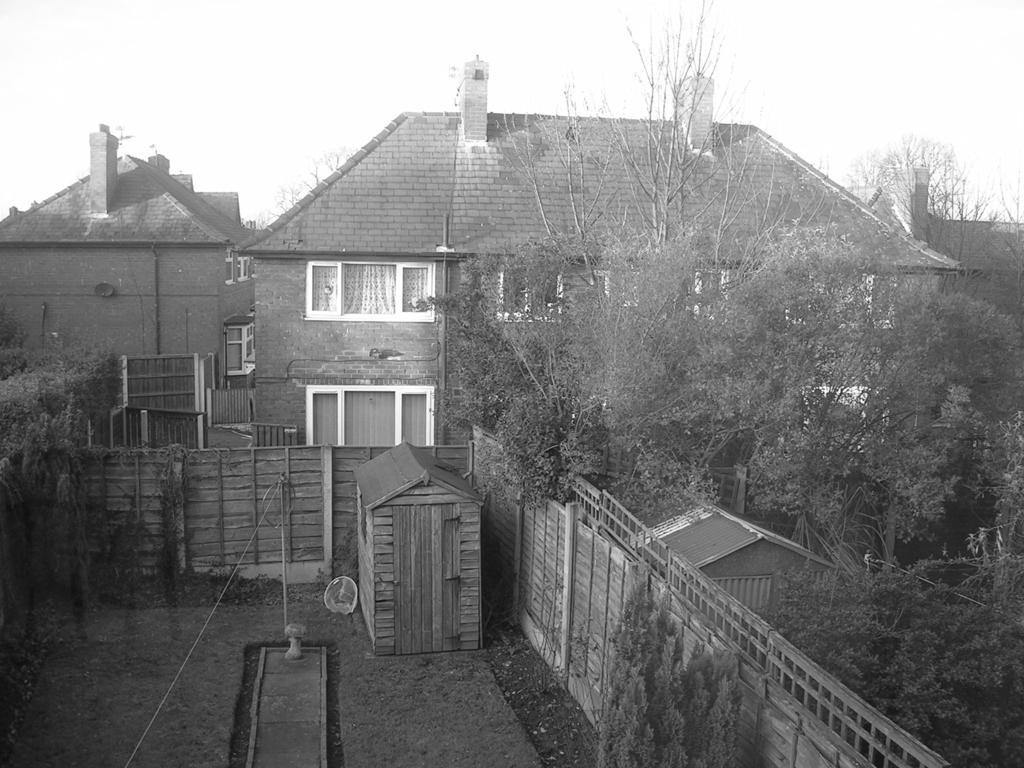What is one of the main objects in the image? There is a pole in the image. What is attached to the pole? There is a rope attached to the pole. What animals are present in the image? There are horses in the image. What type of vegetation can be seen in the image? There are plants and trees in the image. What type of structure is visible in the image? There is a wall and buildings in the image. What architectural feature can be seen in the image? There are windows in the image. What part of the natural environment is visible in the background of the image? The sky is visible in the background of the image. What type of mine can be seen in the image? There is no mine present in the image. How does the wave affect the horses in the image? There is no wave present in the image, so it does not affect the horses. 